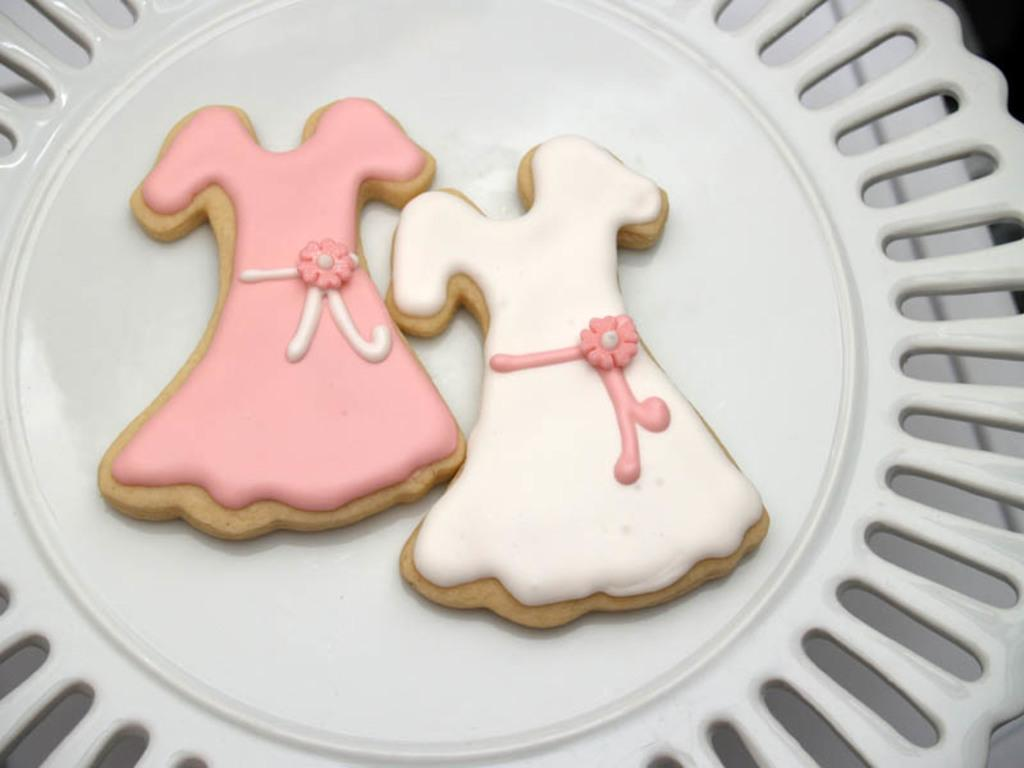What type of food items are in the image? There are two cream biscuits in the image. How are the biscuits shaped? The biscuits are in the shape of a frock. Where are the biscuits placed? The biscuits are on a plate. What type of leaf can be seen on the chin of the person in the image? There is no person or leaf present in the image; it features two cream biscuits on a plate. 